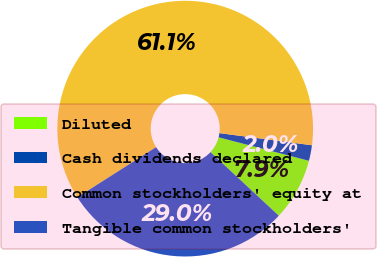Convert chart to OTSL. <chart><loc_0><loc_0><loc_500><loc_500><pie_chart><fcel>Diluted<fcel>Cash dividends declared<fcel>Common stockholders' equity at<fcel>Tangible common stockholders'<nl><fcel>7.88%<fcel>1.97%<fcel>61.1%<fcel>29.05%<nl></chart> 